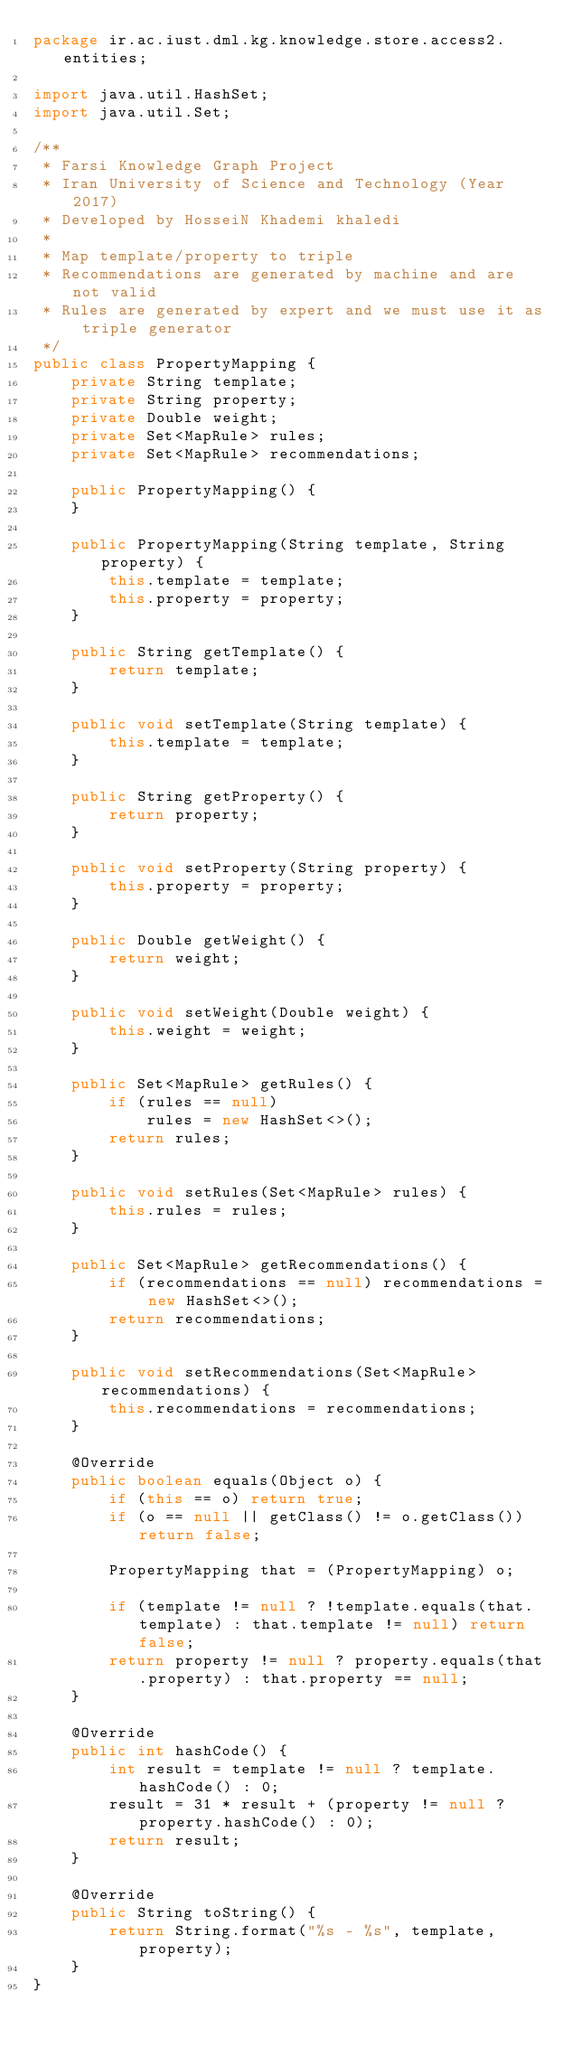Convert code to text. <code><loc_0><loc_0><loc_500><loc_500><_Java_>package ir.ac.iust.dml.kg.knowledge.store.access2.entities;

import java.util.HashSet;
import java.util.Set;

/**
 * Farsi Knowledge Graph Project
 * Iran University of Science and Technology (Year 2017)
 * Developed by HosseiN Khademi khaledi
 *
 * Map template/property to triple
 * Recommendations are generated by machine and are not valid
 * Rules are generated by expert and we must use it as triple generator
 */
public class PropertyMapping {
    private String template;
    private String property;
    private Double weight;
    private Set<MapRule> rules;
    private Set<MapRule> recommendations;

    public PropertyMapping() {
    }

    public PropertyMapping(String template, String property) {
        this.template = template;
        this.property = property;
    }

    public String getTemplate() {
        return template;
    }

    public void setTemplate(String template) {
        this.template = template;
    }

    public String getProperty() {
        return property;
    }

    public void setProperty(String property) {
        this.property = property;
    }

    public Double getWeight() {
        return weight;
    }

    public void setWeight(Double weight) {
        this.weight = weight;
    }

    public Set<MapRule> getRules() {
        if (rules == null)
            rules = new HashSet<>();
        return rules;
    }

    public void setRules(Set<MapRule> rules) {
        this.rules = rules;
    }

    public Set<MapRule> getRecommendations() {
        if (recommendations == null) recommendations = new HashSet<>();
        return recommendations;
    }

    public void setRecommendations(Set<MapRule> recommendations) {
        this.recommendations = recommendations;
    }

    @Override
    public boolean equals(Object o) {
        if (this == o) return true;
        if (o == null || getClass() != o.getClass()) return false;

        PropertyMapping that = (PropertyMapping) o;

        if (template != null ? !template.equals(that.template) : that.template != null) return false;
        return property != null ? property.equals(that.property) : that.property == null;
    }

    @Override
    public int hashCode() {
        int result = template != null ? template.hashCode() : 0;
        result = 31 * result + (property != null ? property.hashCode() : 0);
        return result;
    }

    @Override
    public String toString() {
        return String.format("%s - %s", template, property);
    }
}
</code> 